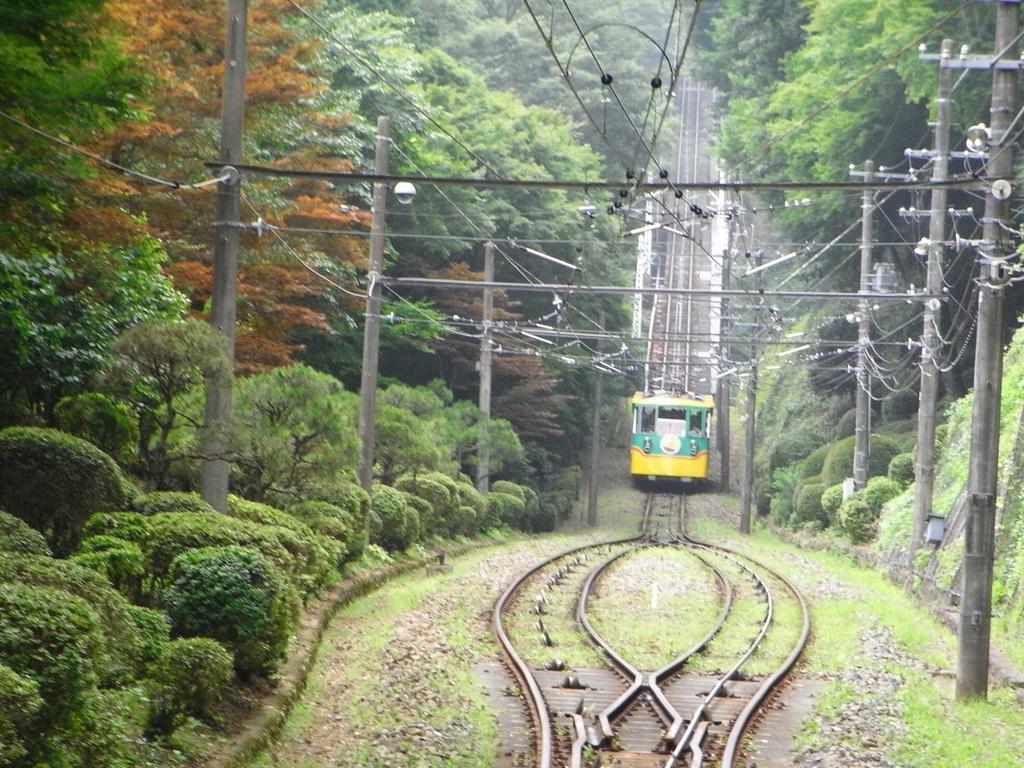How would you summarize this image in a sentence or two? In this image we can see a train on the track. In the center there are poles. In the background there see trees and we can see bushes. At the top there are wires. 